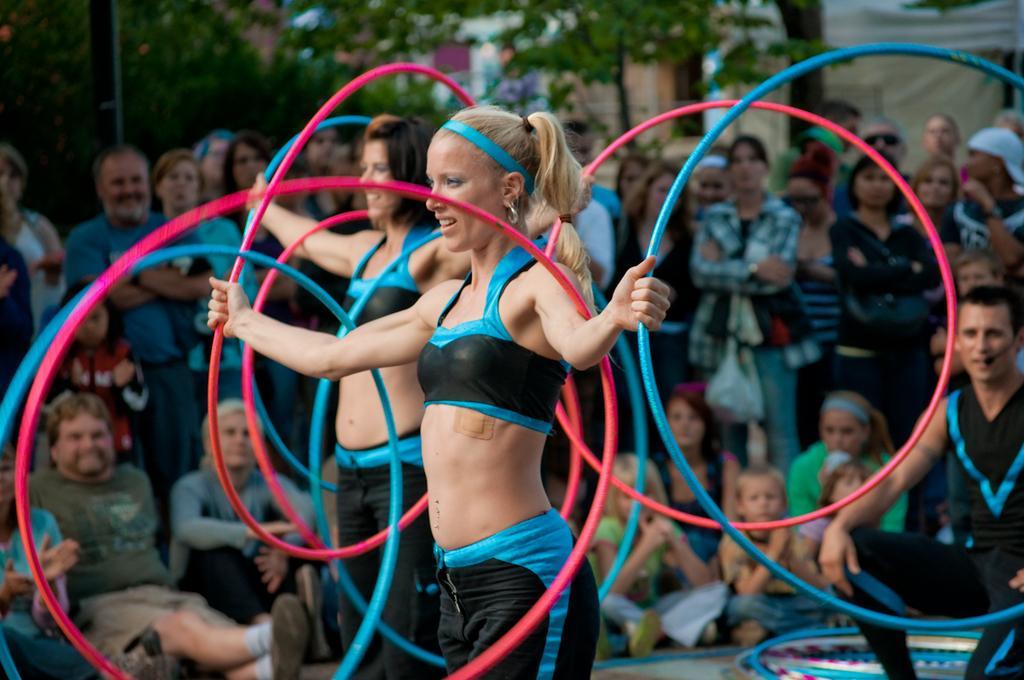Describe this image in one or two sentences. In this picture we can see two women holding rings with their hands and smiling and at the back of them we can see a man sitting and talking on the mic and a group of people and in the background we can see trees. 